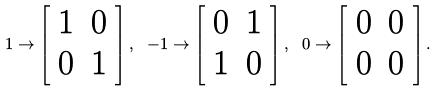<formula> <loc_0><loc_0><loc_500><loc_500>1 \to \left [ \begin{array} { c c } 1 & 0 \\ 0 & 1 \end{array} \right ] , \ - 1 \to \left [ \begin{array} { c c } 0 & 1 \\ 1 & 0 \end{array} \right ] , \ 0 \to \left [ \begin{array} { c c } 0 & 0 \\ 0 & 0 \end{array} \right ] .</formula> 